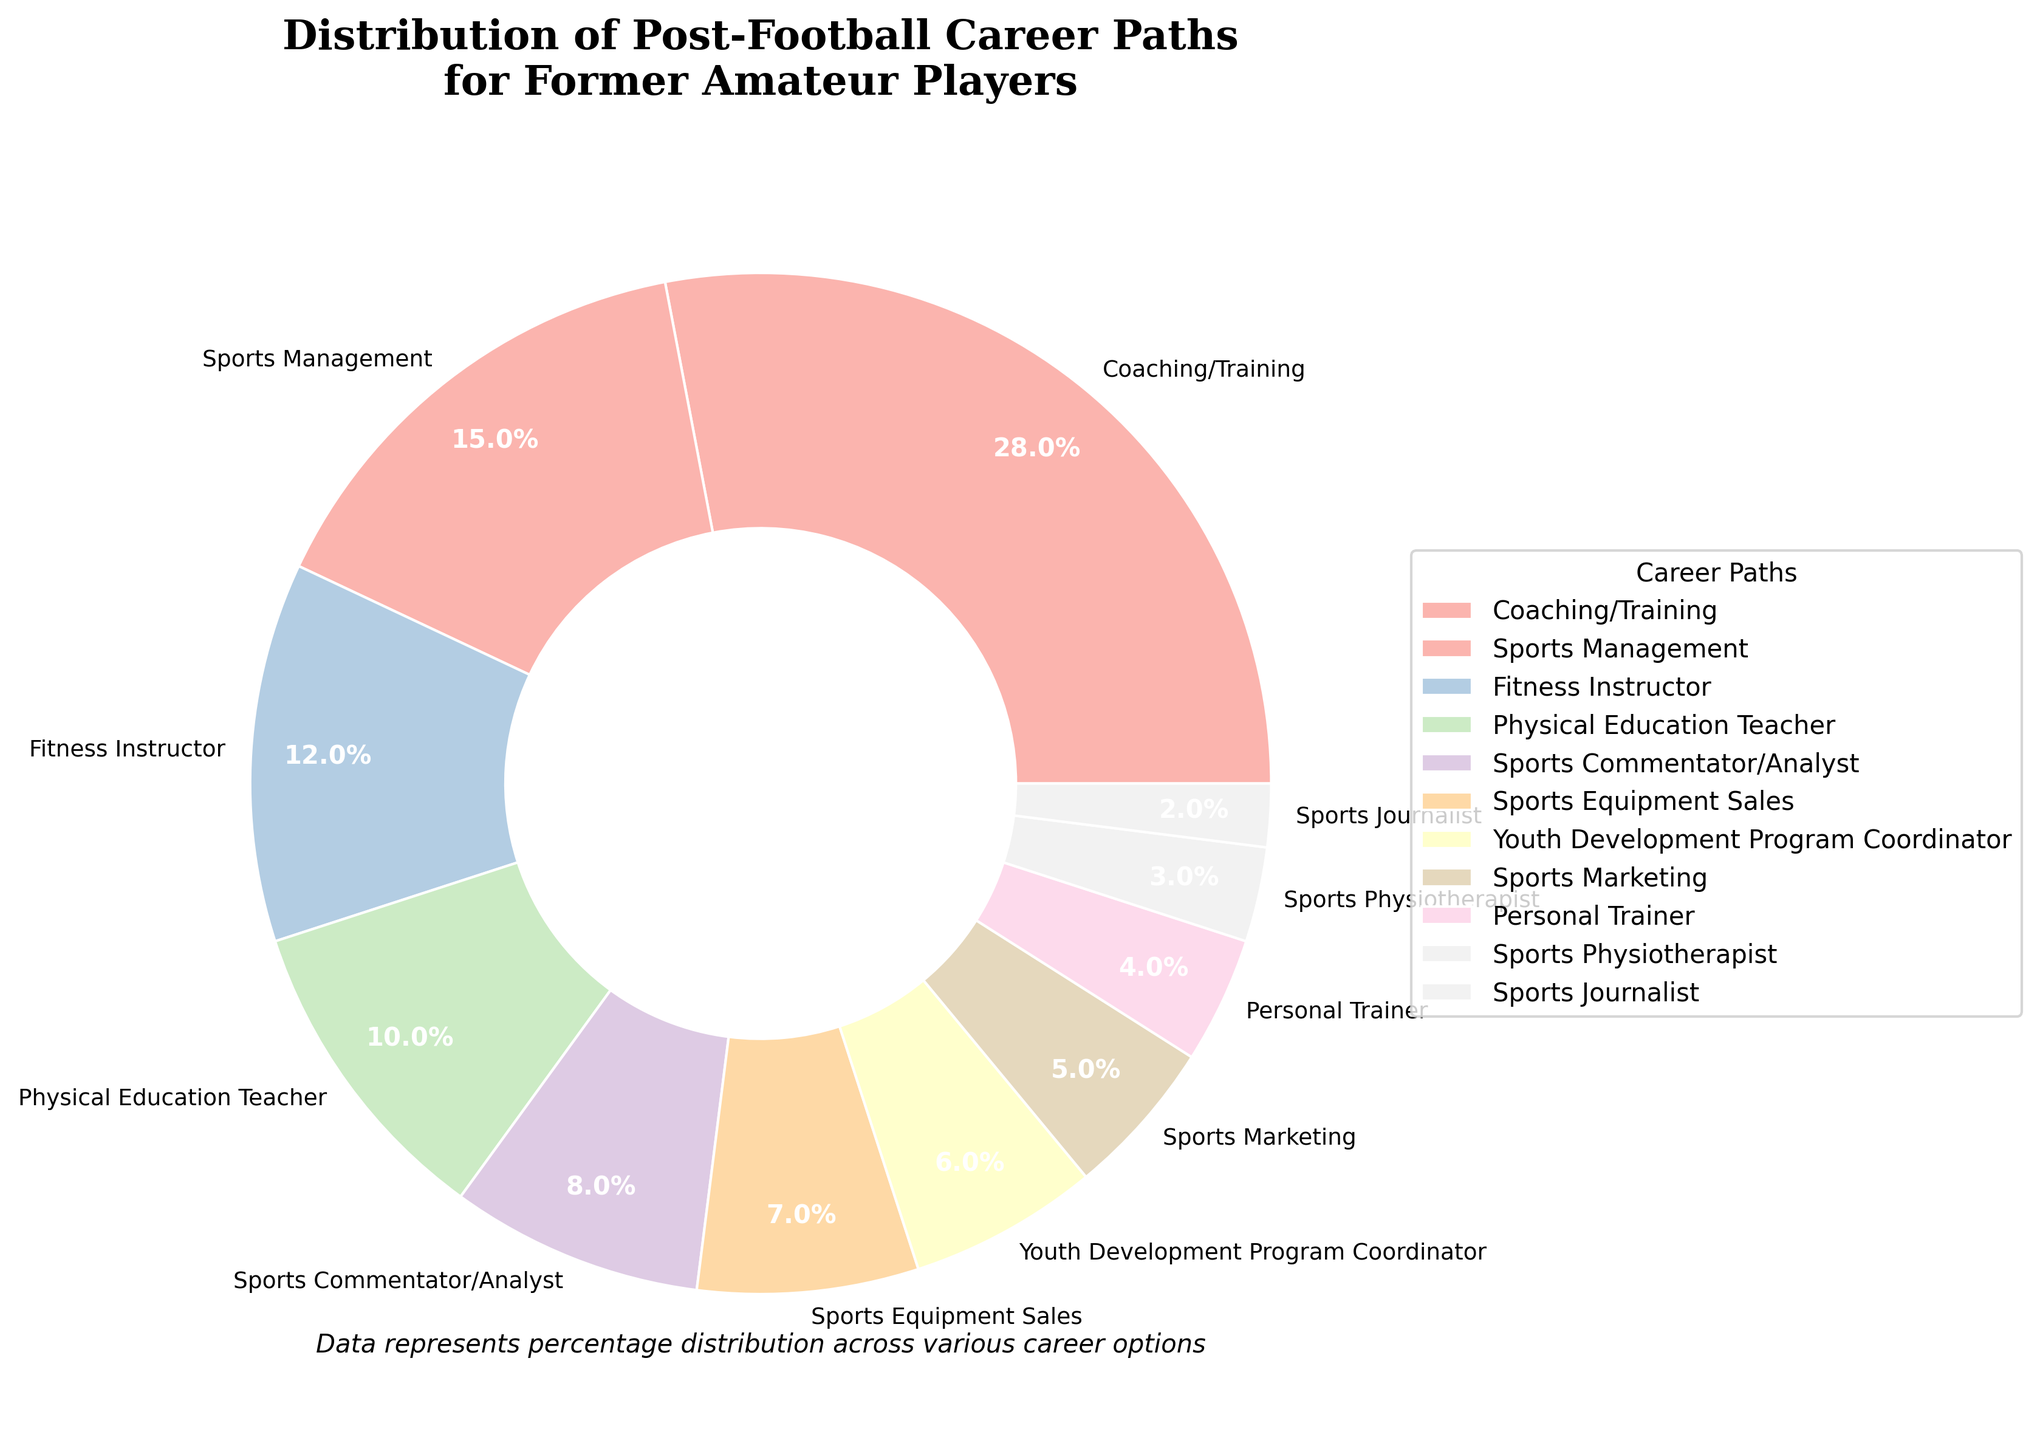What's the most common post-football career path for former amateur players? The pie chart shows that the largest segment is Coaching/Training at 28%.
Answer: Coaching/Training Which career path has a higher percentage: Sports Management or Fitness Instructor? By comparing the percentages, Sports Management at 15% is higher than Fitness Instructor at 12%.
Answer: Sports Management What is the combined percentage of players who go into Personal Training and Sports Physiotherapy? Adding the percentages for Personal Trainer (4%) and Sports Physiotherapist (3%) gives a total of 4 + 3 = 7%.
Answer: 7% How does the percentage of players who become Physical Education Teachers compare to those who become Sports Commentators/Analysts? The pie chart shows Physical Education Teacher at 10% and Sports Commentator/Analyst at 8%; thus, Physical Education Teacher is higher.
Answer: Physical Education Teacher Which career paths have percentages less than 5%? The pie chart indicates that Personal Trainer (4%), Sports Physiotherapist (3%), and Sports Journalist (2%) have percentages less than 5%.
Answer: Personal Trainer, Sports Physiotherapist, Sports Journalist Which two career paths combined equal the percentage of those who go into Coaching/Training? Summing up Physical Education Teacher (10%) and Fitness Instructor (12%) together equals 22%, which is still less than Coaching/Training's 28%. However, when we add Sports Management (15%) to either one, it surpasses 28%. So no exact match is available. But two paths equating 27% together (close to 28%) are Fitness Instructor and Sports Management.
Answer: No exact match, but close options are Fitness Instructor and Sports Management What's the total percentage of players pursuing careers in the education sector (Physical Education Teachers and Youth Development Program Coordinators)? Adding percentages for Physical Education Teacher (10%) and Youth Development Program Coordinator (6%) gives a total of 10 + 6 = 16%.
Answer: 16% Which career path has the least representation according to the pie chart? The smallest segment on the pie chart is Sports Journalist at 2%.
Answer: Sports Journalist 